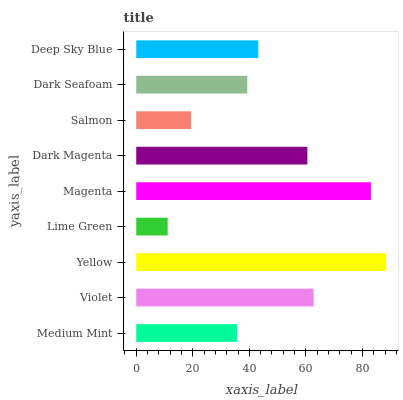Is Lime Green the minimum?
Answer yes or no. Yes. Is Yellow the maximum?
Answer yes or no. Yes. Is Violet the minimum?
Answer yes or no. No. Is Violet the maximum?
Answer yes or no. No. Is Violet greater than Medium Mint?
Answer yes or no. Yes. Is Medium Mint less than Violet?
Answer yes or no. Yes. Is Medium Mint greater than Violet?
Answer yes or no. No. Is Violet less than Medium Mint?
Answer yes or no. No. Is Deep Sky Blue the high median?
Answer yes or no. Yes. Is Deep Sky Blue the low median?
Answer yes or no. Yes. Is Yellow the high median?
Answer yes or no. No. Is Dark Magenta the low median?
Answer yes or no. No. 